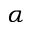Convert formula to latex. <formula><loc_0><loc_0><loc_500><loc_500>\alpha</formula> 